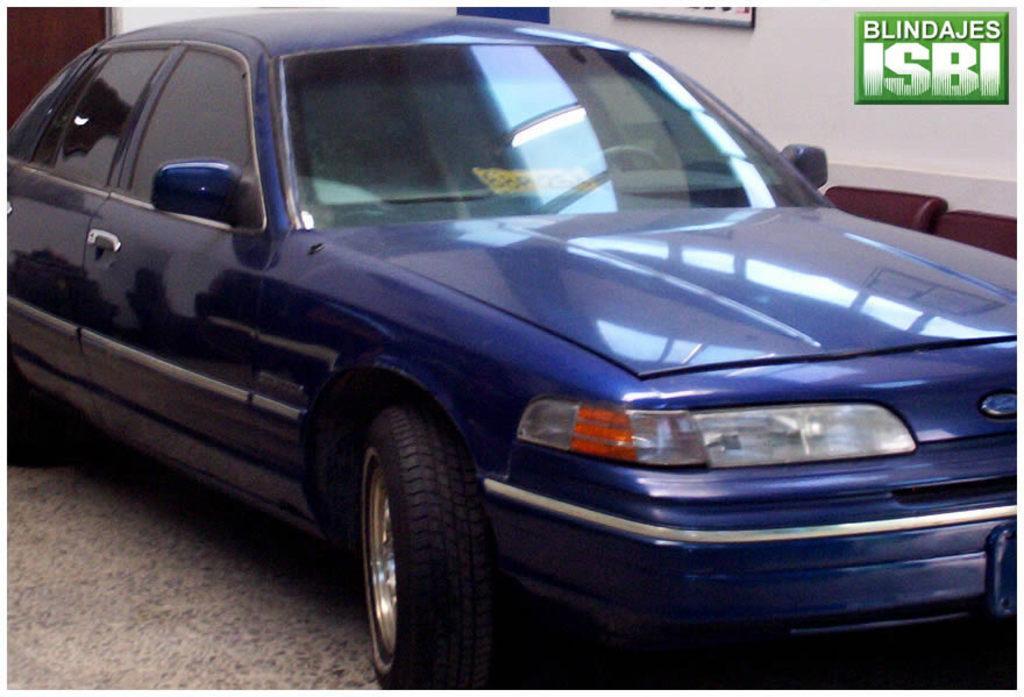How would you summarize this image in a sentence or two? In this picture we can see blue color car is placed, side we can see some boards to the wall. 